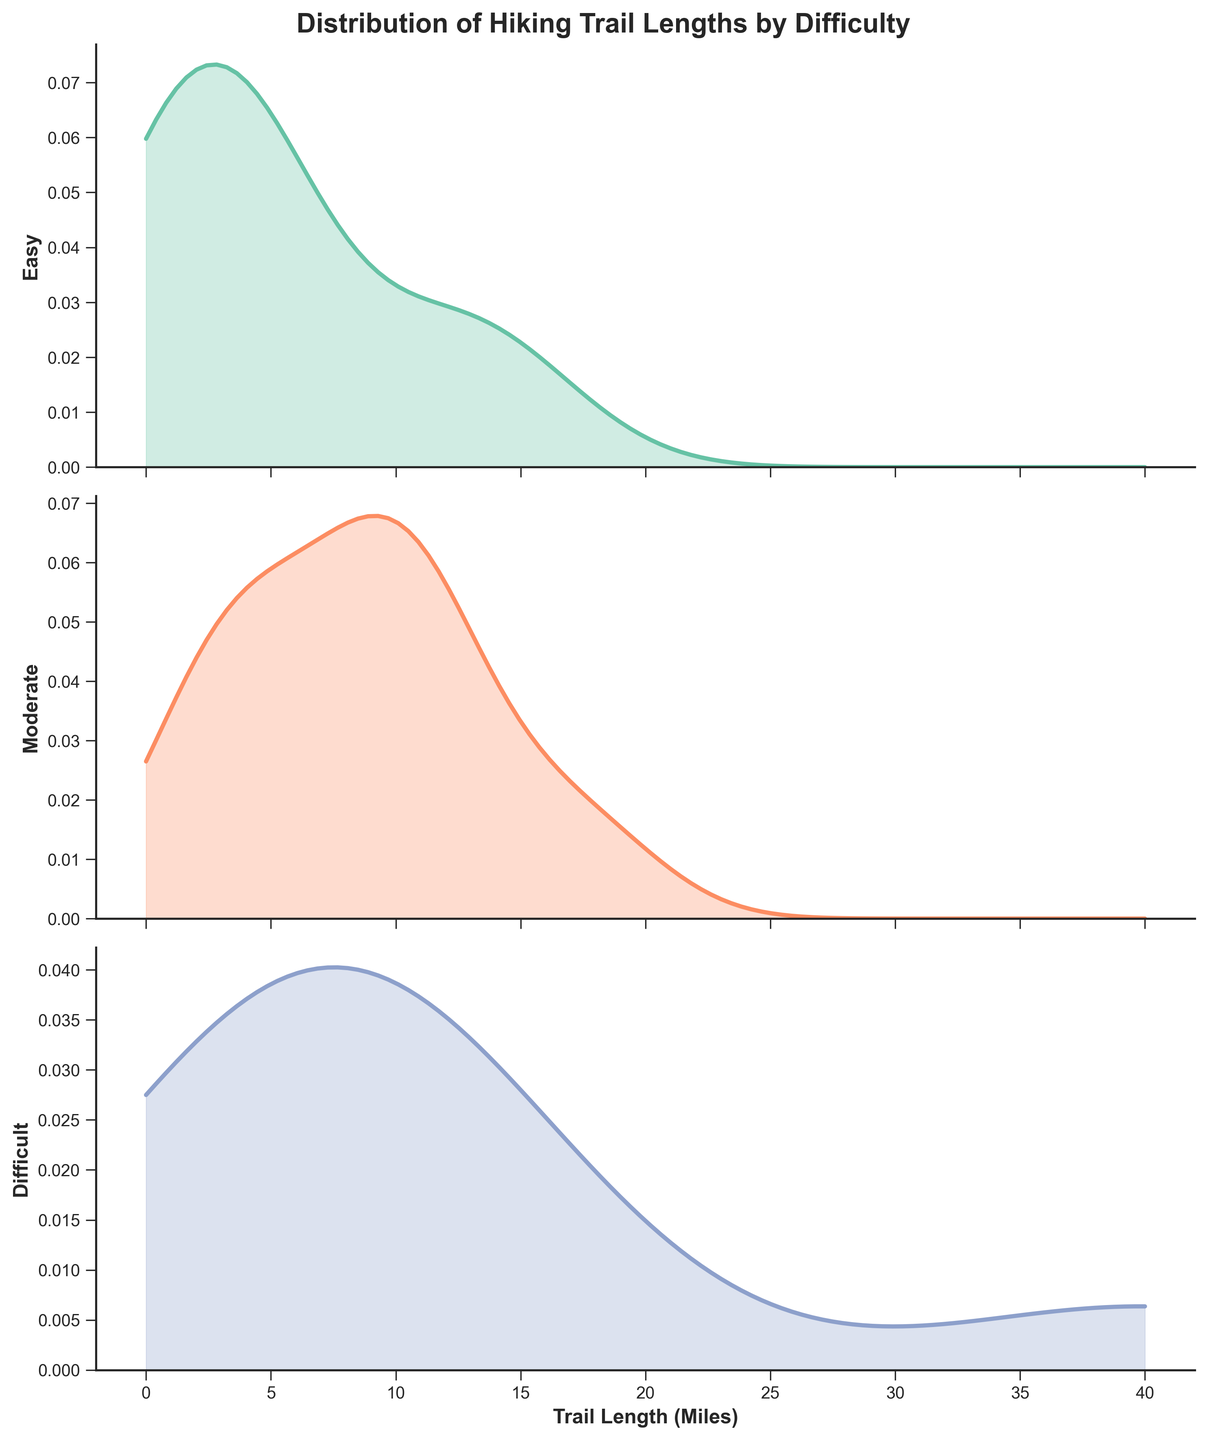What is the title of the figure? The title is displayed at the top of the figure. It reads, "Distribution of Hiking Trail Lengths by Difficulty," indicating the focus of the density plots.
Answer: Distribution of Hiking Trail Lengths by Difficulty Which difficulty level has the broadest spread of trail lengths? The "Moderate" plot has a wider spread across the x-axis, indicating a greater variation in trail lengths.
Answer: Moderate What is the range of trail lengths for 'Difficult' trails? By looking at the x-axis range covered by the density curve for the 'Difficult' category, the trail lengths range from around 0 to 40 miles.
Answer: 0 to 40 miles Is the distribution of 'Easy' trails left-skewed, right-skewed, or symmetric? The density curve for 'Easy' trails rises sharply and then tapers out, indicating a right-skewed distribution (long tail to the right).
Answer: Right-skewed Which difficulty level appears to have the highest density peak? Comparing the height of the density curves, 'Moderate' trails have the highest peak, meaning most of its trails are concentrated around a particular length.
Answer: Moderate Are any 'Easy' trails longer than the longest 'Moderate' trail? By observing the x-axis endpoints of the density curves, 'Easy' trails do not extend beyond the longest 'Moderate' trail, which reaches just above 17 miles.
Answer: No What is the approximate length where the density peak occurs for 'Difficult' trails? The density peak for 'Difficult' trails is around the length where the curve reaches its maximum, approximately at 7 miles.
Answer: Approximately 7 miles Which category of trails shows the least variation in lengths? The 'Easy' trail category has the narrowest band on the x-axis, indicating less variation in trail lengths.
Answer: Easy Can we say that 'Moderate' trails generally have more variety in lengths compared to 'Easy' trails? Why? Yes, the 'Moderate' trails have a wider spread on the x-axis compared to 'Easy' trails, showing a wider variety of lengths.
Answer: Yes Compare the density peaks of 'Easy' and 'Moderate' trails. Which one occurs at a shorter length? The density peak for 'Easy' trails happens at a shorter length than the peak for 'Moderate' trails, which is at approximately 3-4 miles for 'Easy' vs. around 10 miles for 'Moderate'.
Answer: Easy 